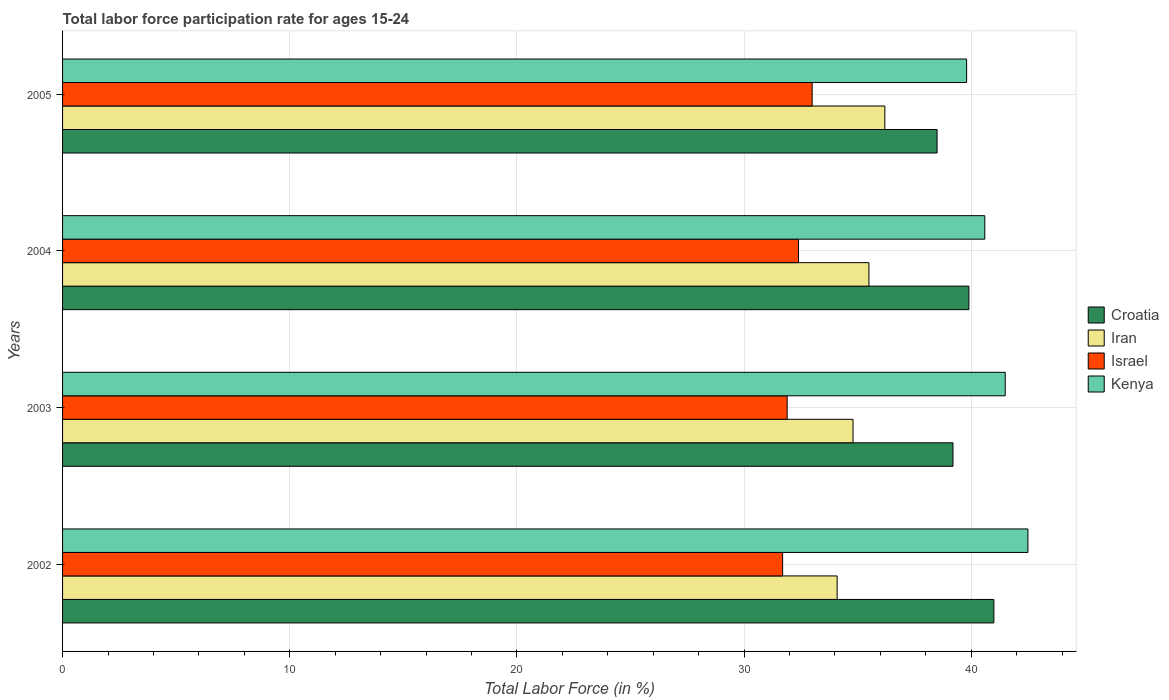How many different coloured bars are there?
Offer a very short reply. 4. How many bars are there on the 2nd tick from the top?
Provide a short and direct response. 4. How many bars are there on the 1st tick from the bottom?
Your answer should be very brief. 4. What is the label of the 3rd group of bars from the top?
Offer a very short reply. 2003. What is the labor force participation rate in Israel in 2004?
Provide a short and direct response. 32.4. Across all years, what is the maximum labor force participation rate in Kenya?
Provide a short and direct response. 42.5. Across all years, what is the minimum labor force participation rate in Iran?
Provide a succinct answer. 34.1. In which year was the labor force participation rate in Iran maximum?
Ensure brevity in your answer.  2005. In which year was the labor force participation rate in Croatia minimum?
Provide a short and direct response. 2005. What is the total labor force participation rate in Iran in the graph?
Your answer should be very brief. 140.6. What is the difference between the labor force participation rate in Kenya in 2002 and that in 2005?
Give a very brief answer. 2.7. What is the difference between the labor force participation rate in Israel in 2005 and the labor force participation rate in Croatia in 2003?
Make the answer very short. -6.2. What is the average labor force participation rate in Croatia per year?
Your response must be concise. 39.65. In the year 2005, what is the difference between the labor force participation rate in Kenya and labor force participation rate in Croatia?
Offer a terse response. 1.3. What is the ratio of the labor force participation rate in Israel in 2002 to that in 2003?
Provide a short and direct response. 0.99. Is the labor force participation rate in Kenya in 2003 less than that in 2005?
Provide a short and direct response. No. What is the difference between the highest and the second highest labor force participation rate in Kenya?
Offer a very short reply. 1. What is the difference between the highest and the lowest labor force participation rate in Croatia?
Your answer should be compact. 2.5. Is it the case that in every year, the sum of the labor force participation rate in Kenya and labor force participation rate in Iran is greater than the sum of labor force participation rate in Croatia and labor force participation rate in Israel?
Keep it short and to the point. No. What does the 1st bar from the top in 2004 represents?
Your answer should be very brief. Kenya. What does the 3rd bar from the bottom in 2003 represents?
Your answer should be very brief. Israel. How many years are there in the graph?
Your answer should be compact. 4. What is the difference between two consecutive major ticks on the X-axis?
Your answer should be very brief. 10. Does the graph contain any zero values?
Your answer should be compact. No. Does the graph contain grids?
Offer a terse response. Yes. How many legend labels are there?
Your answer should be compact. 4. How are the legend labels stacked?
Give a very brief answer. Vertical. What is the title of the graph?
Ensure brevity in your answer.  Total labor force participation rate for ages 15-24. What is the label or title of the Y-axis?
Your response must be concise. Years. What is the Total Labor Force (in %) in Croatia in 2002?
Ensure brevity in your answer.  41. What is the Total Labor Force (in %) of Iran in 2002?
Your response must be concise. 34.1. What is the Total Labor Force (in %) in Israel in 2002?
Keep it short and to the point. 31.7. What is the Total Labor Force (in %) in Kenya in 2002?
Your response must be concise. 42.5. What is the Total Labor Force (in %) of Croatia in 2003?
Ensure brevity in your answer.  39.2. What is the Total Labor Force (in %) of Iran in 2003?
Offer a terse response. 34.8. What is the Total Labor Force (in %) of Israel in 2003?
Your answer should be very brief. 31.9. What is the Total Labor Force (in %) of Kenya in 2003?
Offer a very short reply. 41.5. What is the Total Labor Force (in %) in Croatia in 2004?
Make the answer very short. 39.9. What is the Total Labor Force (in %) of Iran in 2004?
Your answer should be very brief. 35.5. What is the Total Labor Force (in %) of Israel in 2004?
Provide a short and direct response. 32.4. What is the Total Labor Force (in %) of Kenya in 2004?
Provide a short and direct response. 40.6. What is the Total Labor Force (in %) in Croatia in 2005?
Your answer should be very brief. 38.5. What is the Total Labor Force (in %) in Iran in 2005?
Give a very brief answer. 36.2. What is the Total Labor Force (in %) in Kenya in 2005?
Provide a succinct answer. 39.8. Across all years, what is the maximum Total Labor Force (in %) of Croatia?
Your answer should be very brief. 41. Across all years, what is the maximum Total Labor Force (in %) in Iran?
Your response must be concise. 36.2. Across all years, what is the maximum Total Labor Force (in %) of Kenya?
Make the answer very short. 42.5. Across all years, what is the minimum Total Labor Force (in %) in Croatia?
Offer a terse response. 38.5. Across all years, what is the minimum Total Labor Force (in %) of Iran?
Your response must be concise. 34.1. Across all years, what is the minimum Total Labor Force (in %) of Israel?
Make the answer very short. 31.7. Across all years, what is the minimum Total Labor Force (in %) in Kenya?
Provide a succinct answer. 39.8. What is the total Total Labor Force (in %) in Croatia in the graph?
Ensure brevity in your answer.  158.6. What is the total Total Labor Force (in %) of Iran in the graph?
Provide a succinct answer. 140.6. What is the total Total Labor Force (in %) in Israel in the graph?
Give a very brief answer. 129. What is the total Total Labor Force (in %) in Kenya in the graph?
Keep it short and to the point. 164.4. What is the difference between the Total Labor Force (in %) in Israel in 2002 and that in 2004?
Ensure brevity in your answer.  -0.7. What is the difference between the Total Labor Force (in %) of Iran in 2002 and that in 2005?
Your answer should be very brief. -2.1. What is the difference between the Total Labor Force (in %) in Croatia in 2003 and that in 2004?
Offer a terse response. -0.7. What is the difference between the Total Labor Force (in %) in Israel in 2003 and that in 2004?
Offer a very short reply. -0.5. What is the difference between the Total Labor Force (in %) in Kenya in 2003 and that in 2004?
Your answer should be very brief. 0.9. What is the difference between the Total Labor Force (in %) in Israel in 2003 and that in 2005?
Provide a succinct answer. -1.1. What is the difference between the Total Labor Force (in %) in Croatia in 2004 and that in 2005?
Make the answer very short. 1.4. What is the difference between the Total Labor Force (in %) of Israel in 2004 and that in 2005?
Make the answer very short. -0.6. What is the difference between the Total Labor Force (in %) of Croatia in 2002 and the Total Labor Force (in %) of Iran in 2003?
Give a very brief answer. 6.2. What is the difference between the Total Labor Force (in %) in Croatia in 2002 and the Total Labor Force (in %) in Israel in 2003?
Offer a very short reply. 9.1. What is the difference between the Total Labor Force (in %) in Iran in 2002 and the Total Labor Force (in %) in Israel in 2003?
Offer a very short reply. 2.2. What is the difference between the Total Labor Force (in %) in Iran in 2002 and the Total Labor Force (in %) in Kenya in 2003?
Your answer should be very brief. -7.4. What is the difference between the Total Labor Force (in %) in Croatia in 2002 and the Total Labor Force (in %) in Israel in 2004?
Keep it short and to the point. 8.6. What is the difference between the Total Labor Force (in %) in Croatia in 2002 and the Total Labor Force (in %) in Kenya in 2004?
Your answer should be very brief. 0.4. What is the difference between the Total Labor Force (in %) in Iran in 2002 and the Total Labor Force (in %) in Kenya in 2004?
Make the answer very short. -6.5. What is the difference between the Total Labor Force (in %) in Croatia in 2002 and the Total Labor Force (in %) in Israel in 2005?
Ensure brevity in your answer.  8. What is the difference between the Total Labor Force (in %) of Iran in 2002 and the Total Labor Force (in %) of Israel in 2005?
Provide a short and direct response. 1.1. What is the difference between the Total Labor Force (in %) of Iran in 2002 and the Total Labor Force (in %) of Kenya in 2005?
Give a very brief answer. -5.7. What is the difference between the Total Labor Force (in %) of Israel in 2002 and the Total Labor Force (in %) of Kenya in 2005?
Your response must be concise. -8.1. What is the difference between the Total Labor Force (in %) of Croatia in 2003 and the Total Labor Force (in %) of Kenya in 2004?
Make the answer very short. -1.4. What is the difference between the Total Labor Force (in %) of Iran in 2003 and the Total Labor Force (in %) of Israel in 2004?
Offer a terse response. 2.4. What is the difference between the Total Labor Force (in %) of Israel in 2003 and the Total Labor Force (in %) of Kenya in 2004?
Offer a very short reply. -8.7. What is the difference between the Total Labor Force (in %) in Croatia in 2003 and the Total Labor Force (in %) in Iran in 2005?
Give a very brief answer. 3. What is the difference between the Total Labor Force (in %) in Croatia in 2003 and the Total Labor Force (in %) in Israel in 2005?
Make the answer very short. 6.2. What is the difference between the Total Labor Force (in %) in Iran in 2003 and the Total Labor Force (in %) in Kenya in 2005?
Your response must be concise. -5. What is the difference between the Total Labor Force (in %) in Croatia in 2004 and the Total Labor Force (in %) in Iran in 2005?
Ensure brevity in your answer.  3.7. What is the difference between the Total Labor Force (in %) in Iran in 2004 and the Total Labor Force (in %) in Kenya in 2005?
Your answer should be very brief. -4.3. What is the difference between the Total Labor Force (in %) of Israel in 2004 and the Total Labor Force (in %) of Kenya in 2005?
Offer a very short reply. -7.4. What is the average Total Labor Force (in %) in Croatia per year?
Ensure brevity in your answer.  39.65. What is the average Total Labor Force (in %) in Iran per year?
Keep it short and to the point. 35.15. What is the average Total Labor Force (in %) in Israel per year?
Your response must be concise. 32.25. What is the average Total Labor Force (in %) of Kenya per year?
Ensure brevity in your answer.  41.1. In the year 2002, what is the difference between the Total Labor Force (in %) in Croatia and Total Labor Force (in %) in Israel?
Your answer should be very brief. 9.3. In the year 2002, what is the difference between the Total Labor Force (in %) of Iran and Total Labor Force (in %) of Kenya?
Keep it short and to the point. -8.4. In the year 2003, what is the difference between the Total Labor Force (in %) in Croatia and Total Labor Force (in %) in Iran?
Your response must be concise. 4.4. In the year 2003, what is the difference between the Total Labor Force (in %) of Croatia and Total Labor Force (in %) of Kenya?
Provide a succinct answer. -2.3. In the year 2003, what is the difference between the Total Labor Force (in %) of Iran and Total Labor Force (in %) of Israel?
Make the answer very short. 2.9. In the year 2003, what is the difference between the Total Labor Force (in %) in Israel and Total Labor Force (in %) in Kenya?
Keep it short and to the point. -9.6. In the year 2004, what is the difference between the Total Labor Force (in %) of Croatia and Total Labor Force (in %) of Israel?
Provide a succinct answer. 7.5. In the year 2004, what is the difference between the Total Labor Force (in %) of Croatia and Total Labor Force (in %) of Kenya?
Offer a very short reply. -0.7. In the year 2004, what is the difference between the Total Labor Force (in %) of Iran and Total Labor Force (in %) of Kenya?
Offer a terse response. -5.1. In the year 2005, what is the difference between the Total Labor Force (in %) in Croatia and Total Labor Force (in %) in Iran?
Provide a short and direct response. 2.3. In the year 2005, what is the difference between the Total Labor Force (in %) in Croatia and Total Labor Force (in %) in Israel?
Provide a short and direct response. 5.5. In the year 2005, what is the difference between the Total Labor Force (in %) of Iran and Total Labor Force (in %) of Israel?
Give a very brief answer. 3.2. In the year 2005, what is the difference between the Total Labor Force (in %) of Iran and Total Labor Force (in %) of Kenya?
Offer a very short reply. -3.6. In the year 2005, what is the difference between the Total Labor Force (in %) in Israel and Total Labor Force (in %) in Kenya?
Give a very brief answer. -6.8. What is the ratio of the Total Labor Force (in %) in Croatia in 2002 to that in 2003?
Offer a terse response. 1.05. What is the ratio of the Total Labor Force (in %) in Iran in 2002 to that in 2003?
Your answer should be compact. 0.98. What is the ratio of the Total Labor Force (in %) in Kenya in 2002 to that in 2003?
Provide a short and direct response. 1.02. What is the ratio of the Total Labor Force (in %) of Croatia in 2002 to that in 2004?
Give a very brief answer. 1.03. What is the ratio of the Total Labor Force (in %) in Iran in 2002 to that in 2004?
Provide a succinct answer. 0.96. What is the ratio of the Total Labor Force (in %) of Israel in 2002 to that in 2004?
Offer a very short reply. 0.98. What is the ratio of the Total Labor Force (in %) in Kenya in 2002 to that in 2004?
Offer a very short reply. 1.05. What is the ratio of the Total Labor Force (in %) of Croatia in 2002 to that in 2005?
Your answer should be very brief. 1.06. What is the ratio of the Total Labor Force (in %) of Iran in 2002 to that in 2005?
Provide a short and direct response. 0.94. What is the ratio of the Total Labor Force (in %) of Israel in 2002 to that in 2005?
Provide a short and direct response. 0.96. What is the ratio of the Total Labor Force (in %) in Kenya in 2002 to that in 2005?
Make the answer very short. 1.07. What is the ratio of the Total Labor Force (in %) in Croatia in 2003 to that in 2004?
Your response must be concise. 0.98. What is the ratio of the Total Labor Force (in %) in Iran in 2003 to that in 2004?
Your response must be concise. 0.98. What is the ratio of the Total Labor Force (in %) in Israel in 2003 to that in 2004?
Offer a very short reply. 0.98. What is the ratio of the Total Labor Force (in %) in Kenya in 2003 to that in 2004?
Offer a very short reply. 1.02. What is the ratio of the Total Labor Force (in %) of Croatia in 2003 to that in 2005?
Ensure brevity in your answer.  1.02. What is the ratio of the Total Labor Force (in %) of Iran in 2003 to that in 2005?
Your response must be concise. 0.96. What is the ratio of the Total Labor Force (in %) of Israel in 2003 to that in 2005?
Your response must be concise. 0.97. What is the ratio of the Total Labor Force (in %) of Kenya in 2003 to that in 2005?
Make the answer very short. 1.04. What is the ratio of the Total Labor Force (in %) of Croatia in 2004 to that in 2005?
Your answer should be very brief. 1.04. What is the ratio of the Total Labor Force (in %) of Iran in 2004 to that in 2005?
Give a very brief answer. 0.98. What is the ratio of the Total Labor Force (in %) of Israel in 2004 to that in 2005?
Your answer should be compact. 0.98. What is the ratio of the Total Labor Force (in %) in Kenya in 2004 to that in 2005?
Offer a very short reply. 1.02. What is the difference between the highest and the second highest Total Labor Force (in %) of Croatia?
Your response must be concise. 1.1. What is the difference between the highest and the second highest Total Labor Force (in %) in Kenya?
Provide a short and direct response. 1. What is the difference between the highest and the lowest Total Labor Force (in %) of Croatia?
Ensure brevity in your answer.  2.5. 